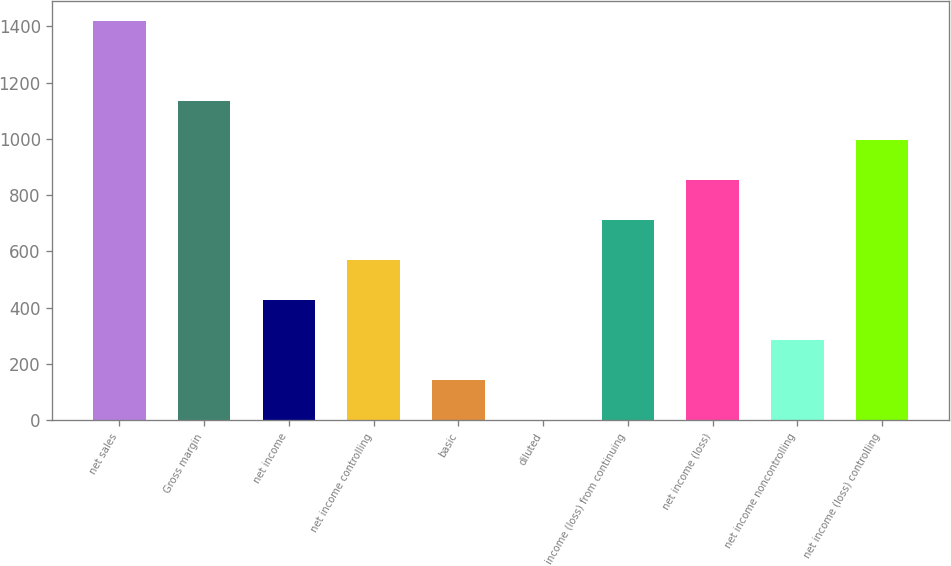<chart> <loc_0><loc_0><loc_500><loc_500><bar_chart><fcel>net sales<fcel>Gross margin<fcel>net income<fcel>net income controlling<fcel>basic<fcel>diluted<fcel>income (loss) from continuing<fcel>net income (loss)<fcel>net income noncontrolling<fcel>net income (loss) controlling<nl><fcel>1420.4<fcel>1136.36<fcel>426.26<fcel>568.28<fcel>142.22<fcel>0.2<fcel>710.3<fcel>852.32<fcel>284.24<fcel>994.34<nl></chart> 